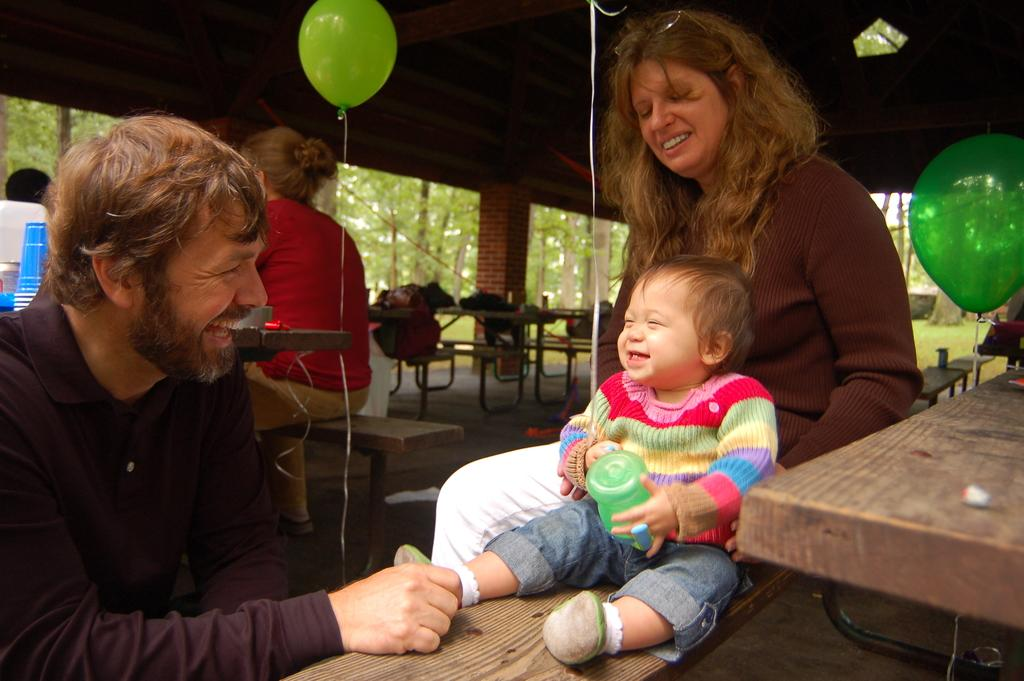What type of natural elements can be seen in the image? There are trees in the image. What additional objects are present in the image? There are balloons in the image. Are there any people in the image? Yes, there are people in the image. Can you describe the specific activity of two people in the image? Two people are sitting on a bench. What items can be seen on a table in the image? There are glasses on a table. What type of animals can be seen in the aftermath of the event in the image? There is no mention of an event or animals in the image; it features trees, balloons, people, and glasses on a table. 